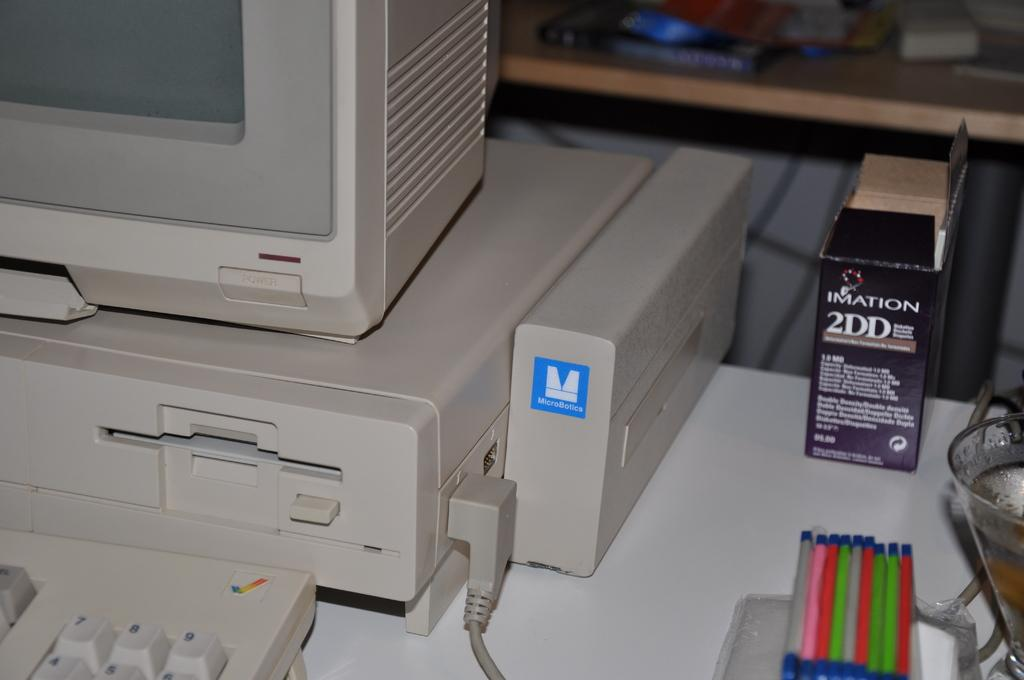What type of electronic device is visible in the image? There is a monitor in the image. What is used for input with the monitor? There is a keyboard in the image for input. What other object can be seen in the image? There is a box in the image. Can you tell me how many blades are on the monitor in the image? There are no blades present on the monitor in the image; it is an electronic device for displaying information. 